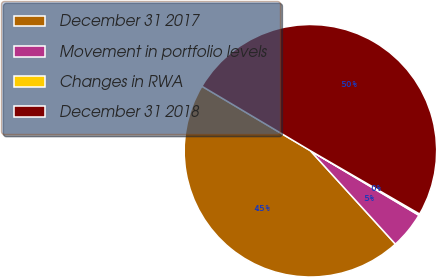Convert chart to OTSL. <chart><loc_0><loc_0><loc_500><loc_500><pie_chart><fcel>December 31 2017<fcel>Movement in portfolio levels<fcel>Changes in RWA<fcel>December 31 2018<nl><fcel>45.29%<fcel>4.71%<fcel>0.18%<fcel>49.82%<nl></chart> 